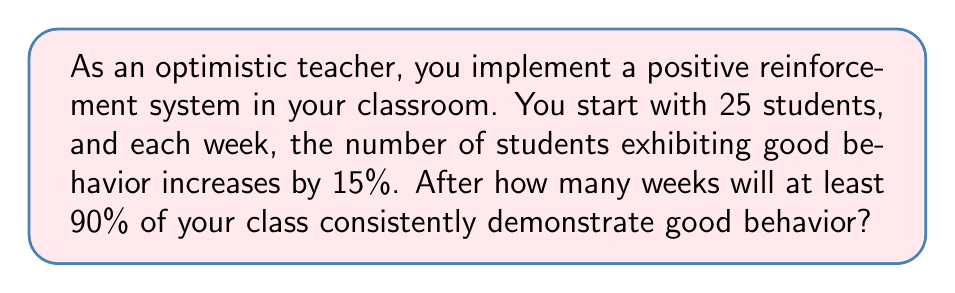Give your solution to this math problem. Let's approach this step-by-step:

1) We start with 25 students, and we want to know when at least 90% (or 22.5 students) will show good behavior.

2) Each week, the number of students with good behavior increases by 15%. We can represent this as a geometric sequence with a common ratio of 1.15.

3) Let $a_n$ be the number of students with good behavior after $n$ weeks, and $a_0 = 25 * 0.15 = 3.75$ (assuming 15% start with good behavior).

4) The sequence is given by: $a_n = 3.75 * (1.15)^n$

5) We want to find $n$ where $a_n \geq 22.5$

6) Solving the inequality:
   $3.75 * (1.15)^n \geq 22.5$
   $(1.15)^n \geq 22.5 / 3.75 = 6$

7) Taking logarithms of both sides:
   $n * \log(1.15) \geq \log(6)$
   $n \geq \log(6) / \log(1.15) \approx 12.33$

8) Since $n$ must be a whole number of weeks, we round up to 13.
Answer: 13 weeks 